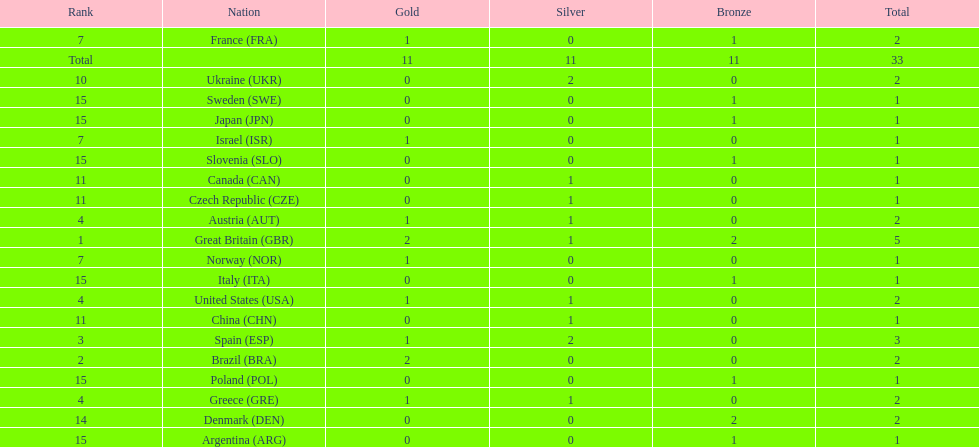Which country has a higher gold medal count than spain? Great Britain (GBR), Brazil (BRA). 